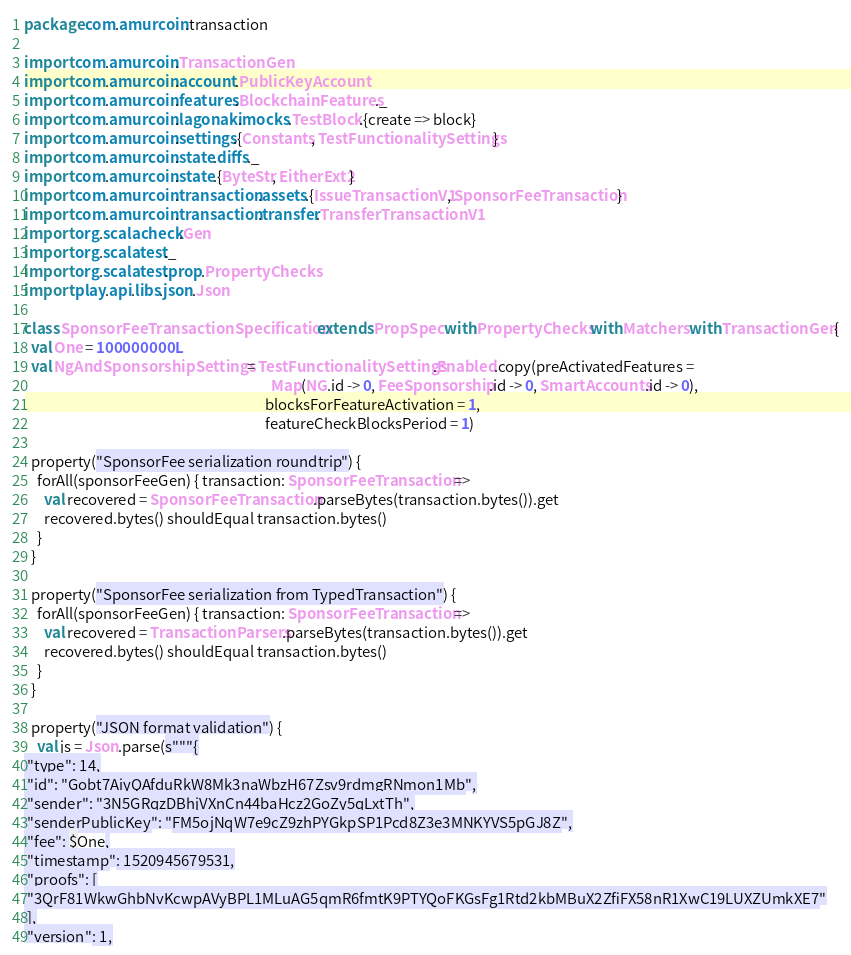<code> <loc_0><loc_0><loc_500><loc_500><_Scala_>package com.amurcoin.transaction

import com.amurcoin.TransactionGen
import com.amurcoin.account.PublicKeyAccount
import com.amurcoin.features.BlockchainFeatures._
import com.amurcoin.lagonaki.mocks.TestBlock.{create => block}
import com.amurcoin.settings.{Constants, TestFunctionalitySettings}
import com.amurcoin.state.diffs._
import com.amurcoin.state.{ByteStr, EitherExt2}
import com.amurcoin.transaction.assets.{IssueTransactionV1, SponsorFeeTransaction}
import com.amurcoin.transaction.transfer.TransferTransactionV1
import org.scalacheck.Gen
import org.scalatest._
import org.scalatest.prop.PropertyChecks
import play.api.libs.json.Json

class SponsorFeeTransactionSpecification extends PropSpec with PropertyChecks with Matchers with TransactionGen {
  val One = 100000000L
  val NgAndSponsorshipSettings = TestFunctionalitySettings.Enabled.copy(preActivatedFeatures =
                                                                          Map(NG.id -> 0, FeeSponsorship.id -> 0, SmartAccounts.id -> 0),
                                                                        blocksForFeatureActivation = 1,
                                                                        featureCheckBlocksPeriod = 1)

  property("SponsorFee serialization roundtrip") {
    forAll(sponsorFeeGen) { transaction: SponsorFeeTransaction =>
      val recovered = SponsorFeeTransaction.parseBytes(transaction.bytes()).get
      recovered.bytes() shouldEqual transaction.bytes()
    }
  }

  property("SponsorFee serialization from TypedTransaction") {
    forAll(sponsorFeeGen) { transaction: SponsorFeeTransaction =>
      val recovered = TransactionParsers.parseBytes(transaction.bytes()).get
      recovered.bytes() shouldEqual transaction.bytes()
    }
  }

  property("JSON format validation") {
    val js = Json.parse(s"""{
 "type": 14,
 "id": "Gobt7AiyQAfduRkW8Mk3naWbzH67Zsv9rdmgRNmon1Mb",
 "sender": "3N5GRqzDBhjVXnCn44baHcz2GoZy5qLxtTh",
 "senderPublicKey": "FM5ojNqW7e9cZ9zhPYGkpSP1Pcd8Z3e3MNKYVS5pGJ8Z",
 "fee": $One,
 "timestamp": 1520945679531,
 "proofs": [
 "3QrF81WkwGhbNvKcwpAVyBPL1MLuAG5qmR6fmtK9PTYQoFKGsFg1Rtd2kbMBuX2ZfiFX58nR1XwC19LUXZUmkXE7"
 ],
 "version": 1,</code> 